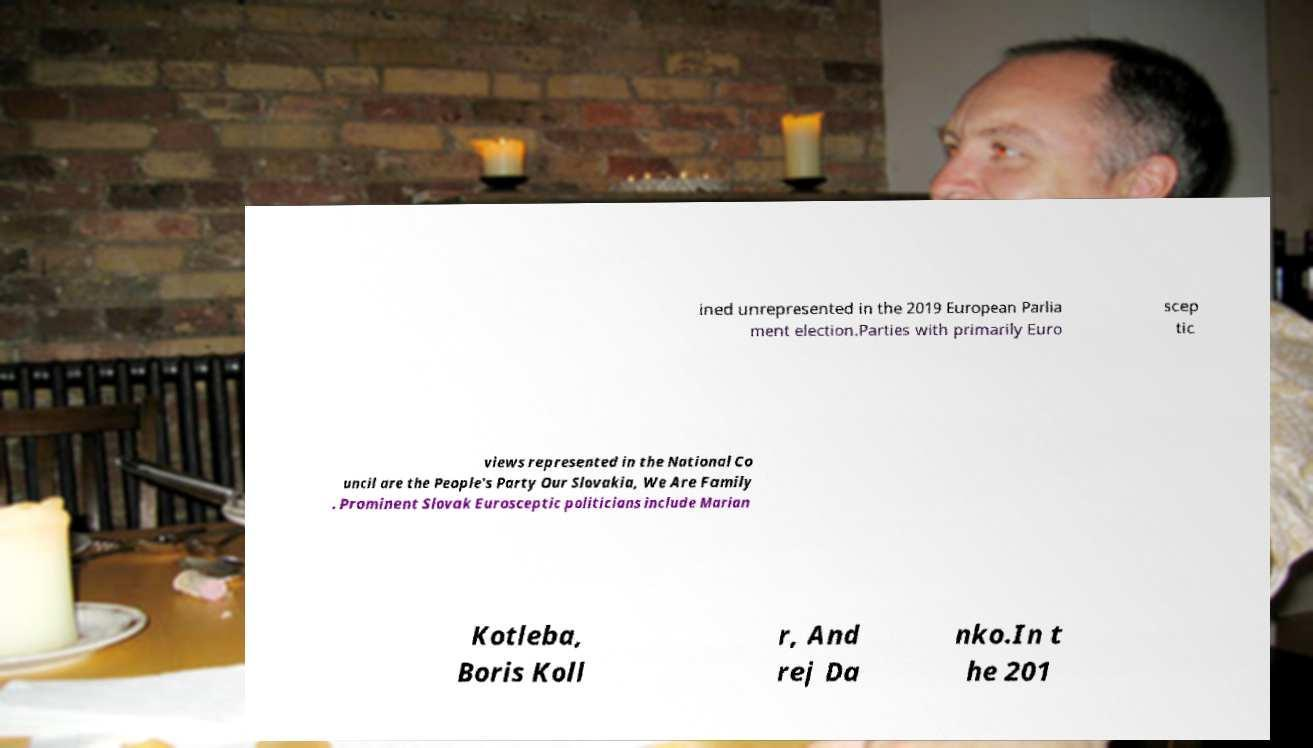There's text embedded in this image that I need extracted. Can you transcribe it verbatim? ined unrepresented in the 2019 European Parlia ment election.Parties with primarily Euro scep tic views represented in the National Co uncil are the People's Party Our Slovakia, We Are Family . Prominent Slovak Eurosceptic politicians include Marian Kotleba, Boris Koll r, And rej Da nko.In t he 201 